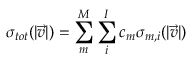<formula> <loc_0><loc_0><loc_500><loc_500>\sigma _ { t o t } ( | \vec { v } | ) = \sum _ { m } ^ { M } \sum _ { i } ^ { I } c _ { m } \sigma _ { m , i } ( | \vec { v } | )</formula> 